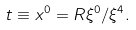Convert formula to latex. <formula><loc_0><loc_0><loc_500><loc_500>t \equiv x ^ { 0 } = R \xi ^ { 0 } / \xi ^ { 4 } .</formula> 